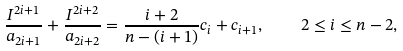Convert formula to latex. <formula><loc_0><loc_0><loc_500><loc_500>\frac { I ^ { 2 i + 1 } } { a _ { 2 i + 1 } } + \frac { I ^ { 2 i + 2 } } { a _ { 2 i + 2 } } = \frac { i + 2 } { n - ( i + 1 ) } c _ { i } + c _ { i + 1 } , \quad 2 \leq i \leq n - 2 ,</formula> 